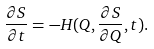Convert formula to latex. <formula><loc_0><loc_0><loc_500><loc_500>\frac { \partial S } { \partial t } = - H ( Q , \frac { \partial S } { \partial Q } , t ) .</formula> 